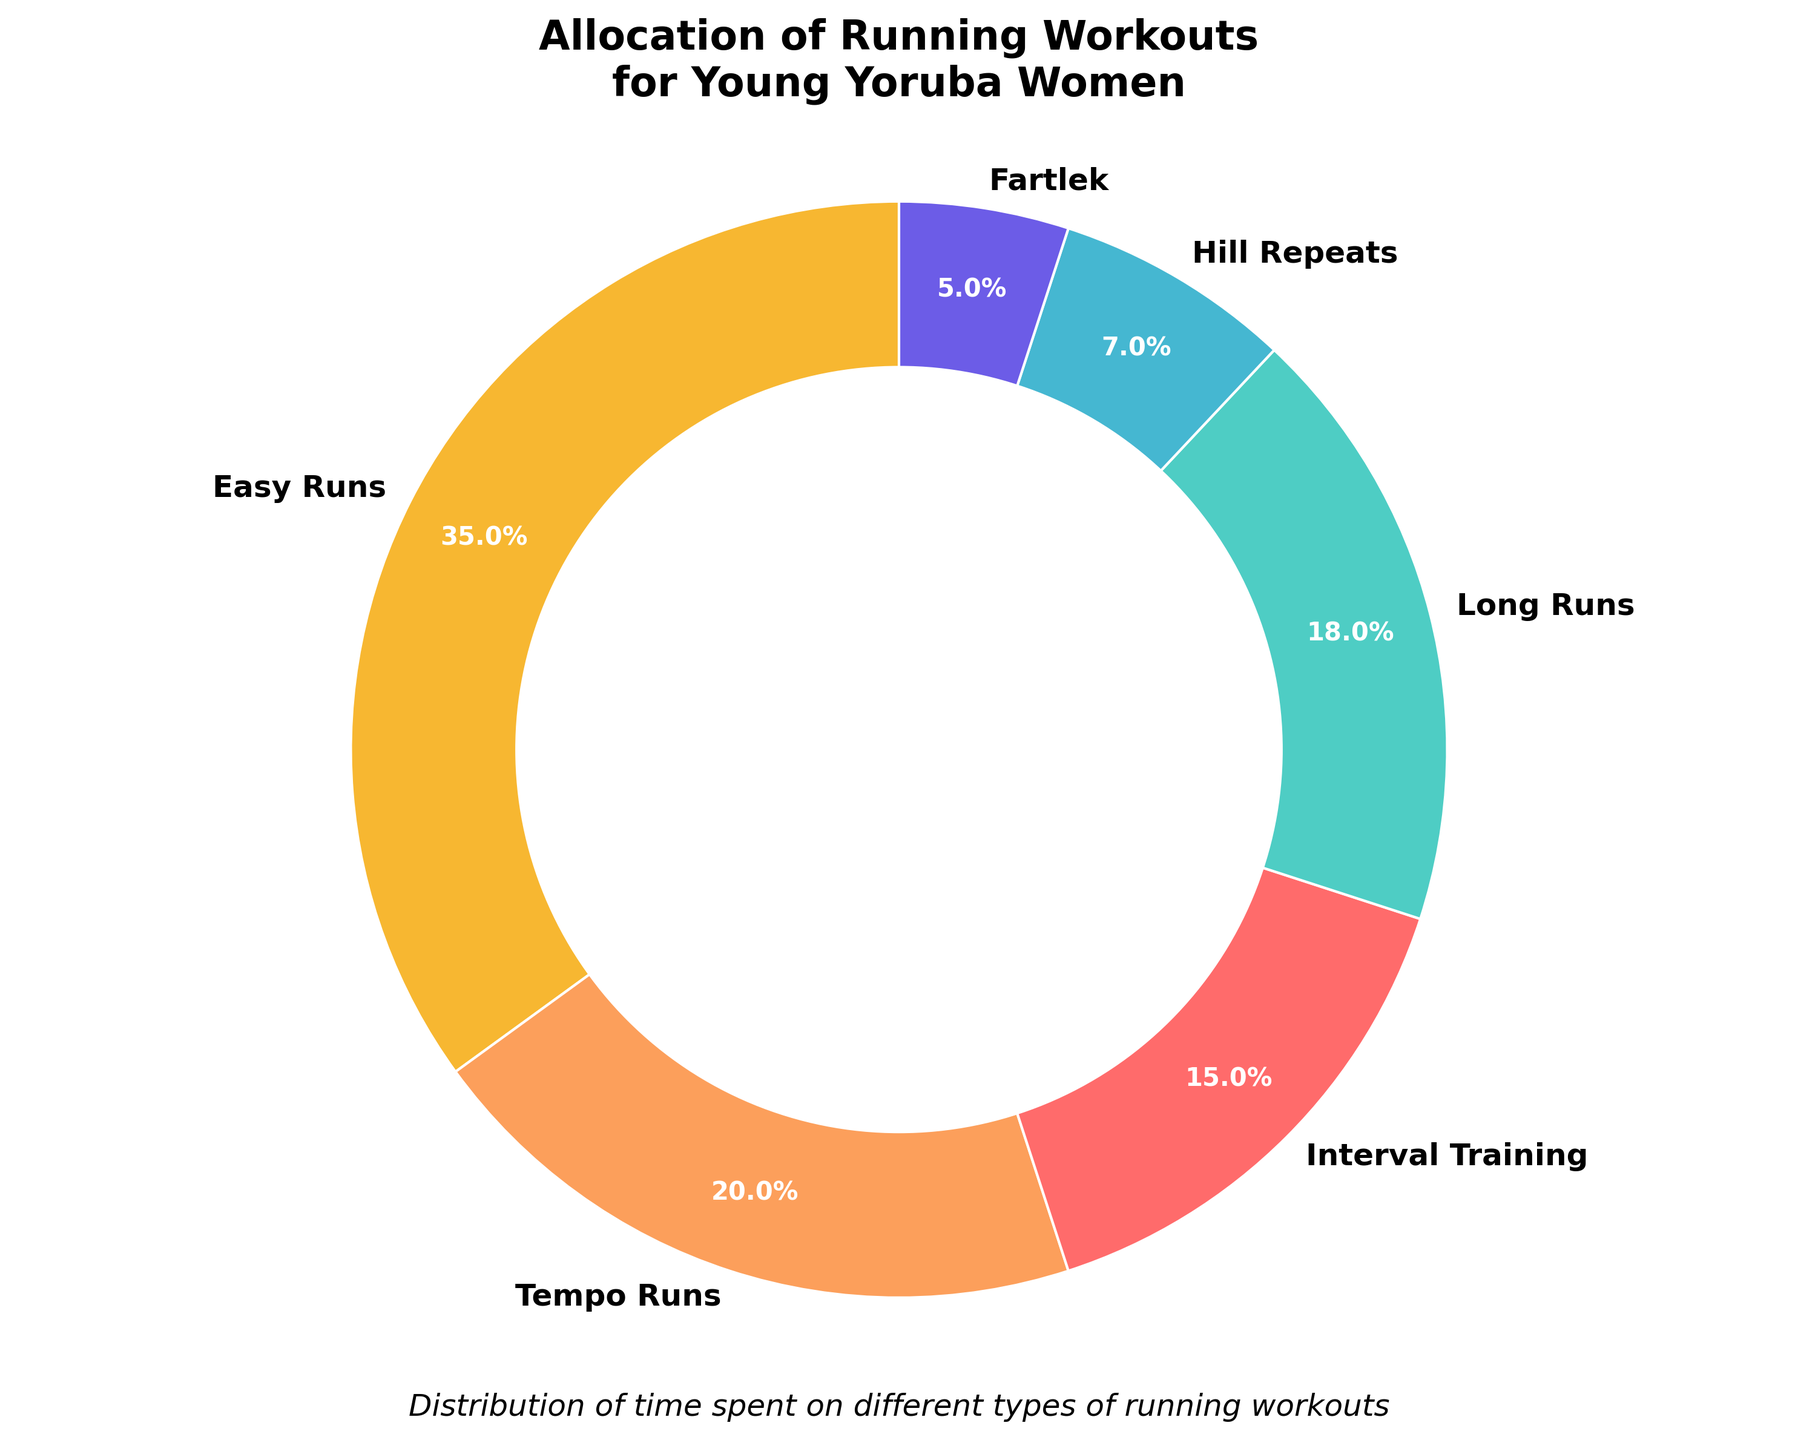What type of workout takes up the largest percentage of time? The figure shows that "Easy Runs" occupies the largest slice of the pie chart, which has the highest percentage displayed.
Answer: Easy Runs How much more time is spent on Easy Runs compared to Tempo Runs? Easy Runs account for 35% of the time, while Tempo Runs account for 20%. Subtracting these percentages gives 35% - 20% = 15%.
Answer: 15% What is the combined percentage of time spent on Interval Training and Long Runs? According to the figure, Interval Training accounts for 15% and Long Runs account for 18%. Adding these percentages gives 15% + 18% = 33%.
Answer: 33% Which workout is represented with the smallest portion of the pie chart? The smallest slice of the pie chart is "Fartlek," which has the lowest percentage displayed.
Answer: Fartlek Is there more time spent on Hill Repeats or Fartlek, and by how much? Hill Repeats account for 7% while Fartlek accounts for 5%. Subtracting these percentages gives 7% - 5% = 2%.
Answer: Hill Repeats by 2% What type of workout takes up one-quarter of the total workout time? The label "Tempo Runs" indicates a 20% allocation. While this is less than one-quarter, it's the closest value to 25% compared to all other workouts.
Answer: None What percentage of time is not allocated to Long Runs or Tempo Runs? The percentage not allocated to Long Runs or Tempo Runs involves subtracting their combined percentage from 100%. Long Runs (18%) + Tempo Runs (20%) = 38%, and 100% - 38% = 62%.
Answer: 62% How does the time spent on Interval Training compare to the time spent on Easy Runs? Interval Training takes up 15% of the total time, whereas Easy Runs take up 35%. Comparing these, Interval Training is less than Easy Runs.
Answer: Less Which two types of workouts have the smallest difference in time allocation? By comparing the differences, “Hill Repeats” at 7% and “Fartlek” at 5% have the smallest difference. 7% - 5% = 2%.
Answer: Hill Repeats and Fartlek What's the total time allocation for all types of runs other than Easy Runs? Easy Runs take up 35%, so the remaining percentage for other runs is 100% - 35% = 65%.
Answer: 65% 